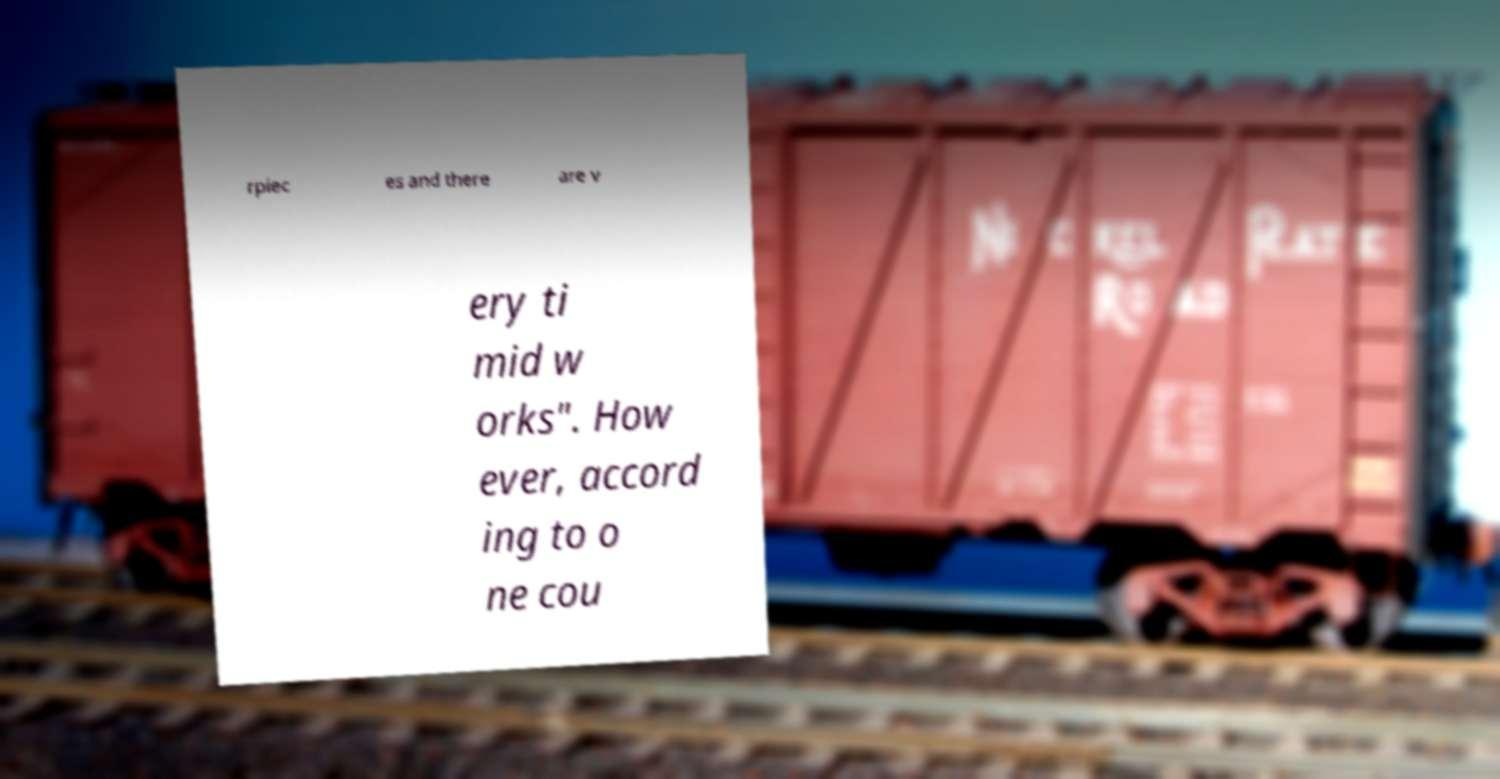Please identify and transcribe the text found in this image. rpiec es and there are v ery ti mid w orks". How ever, accord ing to o ne cou 